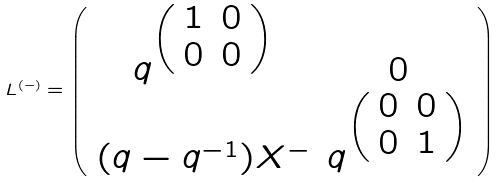<formula> <loc_0><loc_0><loc_500><loc_500>L ^ { ( - ) } = \left ( \begin{array} { c c } q ^ { \left ( \begin{array} { c c } 1 & 0 \\ 0 & 0 \end{array} \right ) } & 0 \\ ( q - q ^ { - 1 } ) X ^ { - } & q ^ { \left ( \begin{array} { c c } 0 & 0 \\ 0 & 1 \end{array} \right ) } \end{array} \right )</formula> 